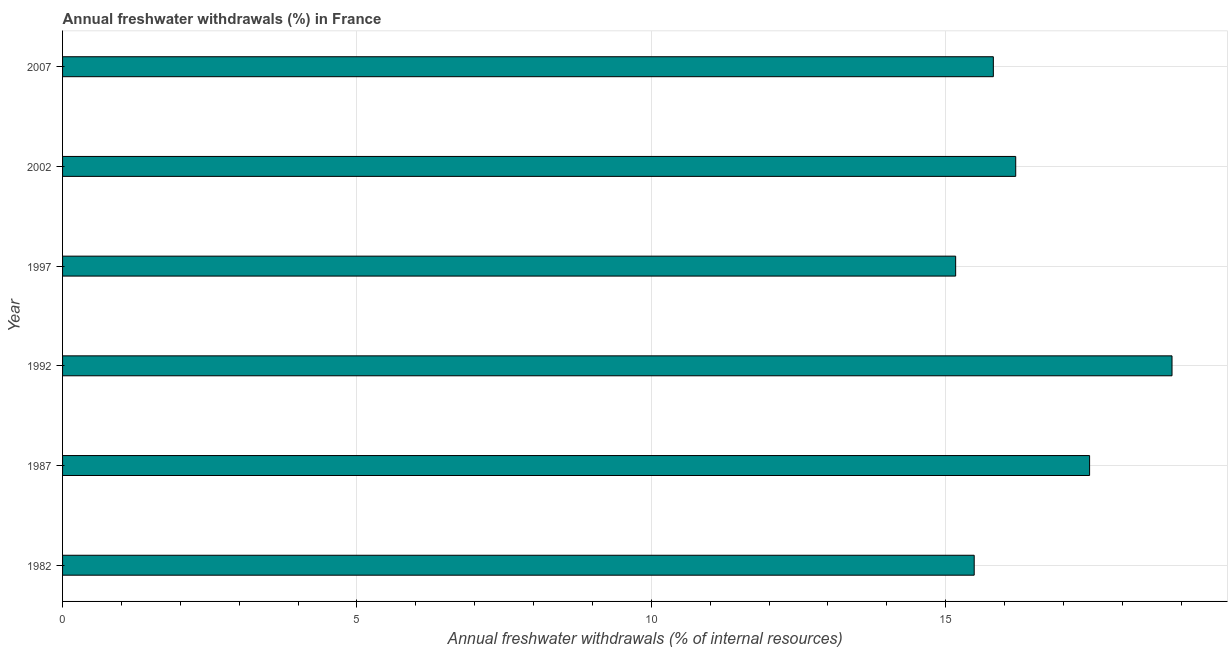Does the graph contain grids?
Your response must be concise. Yes. What is the title of the graph?
Your answer should be very brief. Annual freshwater withdrawals (%) in France. What is the label or title of the X-axis?
Offer a terse response. Annual freshwater withdrawals (% of internal resources). What is the label or title of the Y-axis?
Provide a short and direct response. Year. What is the annual freshwater withdrawals in 1982?
Your answer should be very brief. 15.48. Across all years, what is the maximum annual freshwater withdrawals?
Your answer should be very brief. 18.84. Across all years, what is the minimum annual freshwater withdrawals?
Offer a very short reply. 15.17. What is the sum of the annual freshwater withdrawals?
Offer a very short reply. 98.94. What is the difference between the annual freshwater withdrawals in 1982 and 1987?
Your response must be concise. -1.96. What is the average annual freshwater withdrawals per year?
Keep it short and to the point. 16.49. What is the median annual freshwater withdrawals?
Your answer should be compact. 16. In how many years, is the annual freshwater withdrawals greater than 10 %?
Ensure brevity in your answer.  6. What is the ratio of the annual freshwater withdrawals in 1987 to that in 2007?
Offer a very short reply. 1.1. Is the annual freshwater withdrawals in 1987 less than that in 2007?
Your answer should be very brief. No. What is the difference between the highest and the second highest annual freshwater withdrawals?
Offer a terse response. 1.4. Is the sum of the annual freshwater withdrawals in 1987 and 2002 greater than the maximum annual freshwater withdrawals across all years?
Give a very brief answer. Yes. What is the difference between the highest and the lowest annual freshwater withdrawals?
Offer a terse response. 3.67. In how many years, is the annual freshwater withdrawals greater than the average annual freshwater withdrawals taken over all years?
Provide a succinct answer. 2. Are the values on the major ticks of X-axis written in scientific E-notation?
Ensure brevity in your answer.  No. What is the Annual freshwater withdrawals (% of internal resources) in 1982?
Your response must be concise. 15.48. What is the Annual freshwater withdrawals (% of internal resources) of 1987?
Your answer should be compact. 17.45. What is the Annual freshwater withdrawals (% of internal resources) of 1992?
Your answer should be very brief. 18.84. What is the Annual freshwater withdrawals (% of internal resources) of 1997?
Your answer should be compact. 15.17. What is the Annual freshwater withdrawals (% of internal resources) in 2002?
Make the answer very short. 16.19. What is the Annual freshwater withdrawals (% of internal resources) of 2007?
Your answer should be very brief. 15.81. What is the difference between the Annual freshwater withdrawals (% of internal resources) in 1982 and 1987?
Make the answer very short. -1.96. What is the difference between the Annual freshwater withdrawals (% of internal resources) in 1982 and 1992?
Make the answer very short. -3.36. What is the difference between the Annual freshwater withdrawals (% of internal resources) in 1982 and 1997?
Ensure brevity in your answer.  0.32. What is the difference between the Annual freshwater withdrawals (% of internal resources) in 1982 and 2002?
Keep it short and to the point. -0.7. What is the difference between the Annual freshwater withdrawals (% of internal resources) in 1982 and 2007?
Your answer should be very brief. -0.33. What is the difference between the Annual freshwater withdrawals (% of internal resources) in 1987 and 1997?
Ensure brevity in your answer.  2.27. What is the difference between the Annual freshwater withdrawals (% of internal resources) in 1987 and 2002?
Offer a terse response. 1.25. What is the difference between the Annual freshwater withdrawals (% of internal resources) in 1987 and 2007?
Give a very brief answer. 1.64. What is the difference between the Annual freshwater withdrawals (% of internal resources) in 1992 and 1997?
Make the answer very short. 3.67. What is the difference between the Annual freshwater withdrawals (% of internal resources) in 1992 and 2002?
Your response must be concise. 2.65. What is the difference between the Annual freshwater withdrawals (% of internal resources) in 1992 and 2007?
Provide a short and direct response. 3.04. What is the difference between the Annual freshwater withdrawals (% of internal resources) in 1997 and 2002?
Provide a succinct answer. -1.02. What is the difference between the Annual freshwater withdrawals (% of internal resources) in 1997 and 2007?
Your response must be concise. -0.64. What is the difference between the Annual freshwater withdrawals (% of internal resources) in 2002 and 2007?
Offer a very short reply. 0.38. What is the ratio of the Annual freshwater withdrawals (% of internal resources) in 1982 to that in 1987?
Your answer should be compact. 0.89. What is the ratio of the Annual freshwater withdrawals (% of internal resources) in 1982 to that in 1992?
Your answer should be compact. 0.82. What is the ratio of the Annual freshwater withdrawals (% of internal resources) in 1982 to that in 1997?
Keep it short and to the point. 1.02. What is the ratio of the Annual freshwater withdrawals (% of internal resources) in 1982 to that in 2002?
Your answer should be very brief. 0.96. What is the ratio of the Annual freshwater withdrawals (% of internal resources) in 1987 to that in 1992?
Your answer should be compact. 0.93. What is the ratio of the Annual freshwater withdrawals (% of internal resources) in 1987 to that in 1997?
Make the answer very short. 1.15. What is the ratio of the Annual freshwater withdrawals (% of internal resources) in 1987 to that in 2002?
Your answer should be compact. 1.08. What is the ratio of the Annual freshwater withdrawals (% of internal resources) in 1987 to that in 2007?
Ensure brevity in your answer.  1.1. What is the ratio of the Annual freshwater withdrawals (% of internal resources) in 1992 to that in 1997?
Your answer should be compact. 1.24. What is the ratio of the Annual freshwater withdrawals (% of internal resources) in 1992 to that in 2002?
Provide a short and direct response. 1.16. What is the ratio of the Annual freshwater withdrawals (% of internal resources) in 1992 to that in 2007?
Provide a short and direct response. 1.19. What is the ratio of the Annual freshwater withdrawals (% of internal resources) in 1997 to that in 2002?
Ensure brevity in your answer.  0.94. What is the ratio of the Annual freshwater withdrawals (% of internal resources) in 2002 to that in 2007?
Your answer should be very brief. 1.02. 